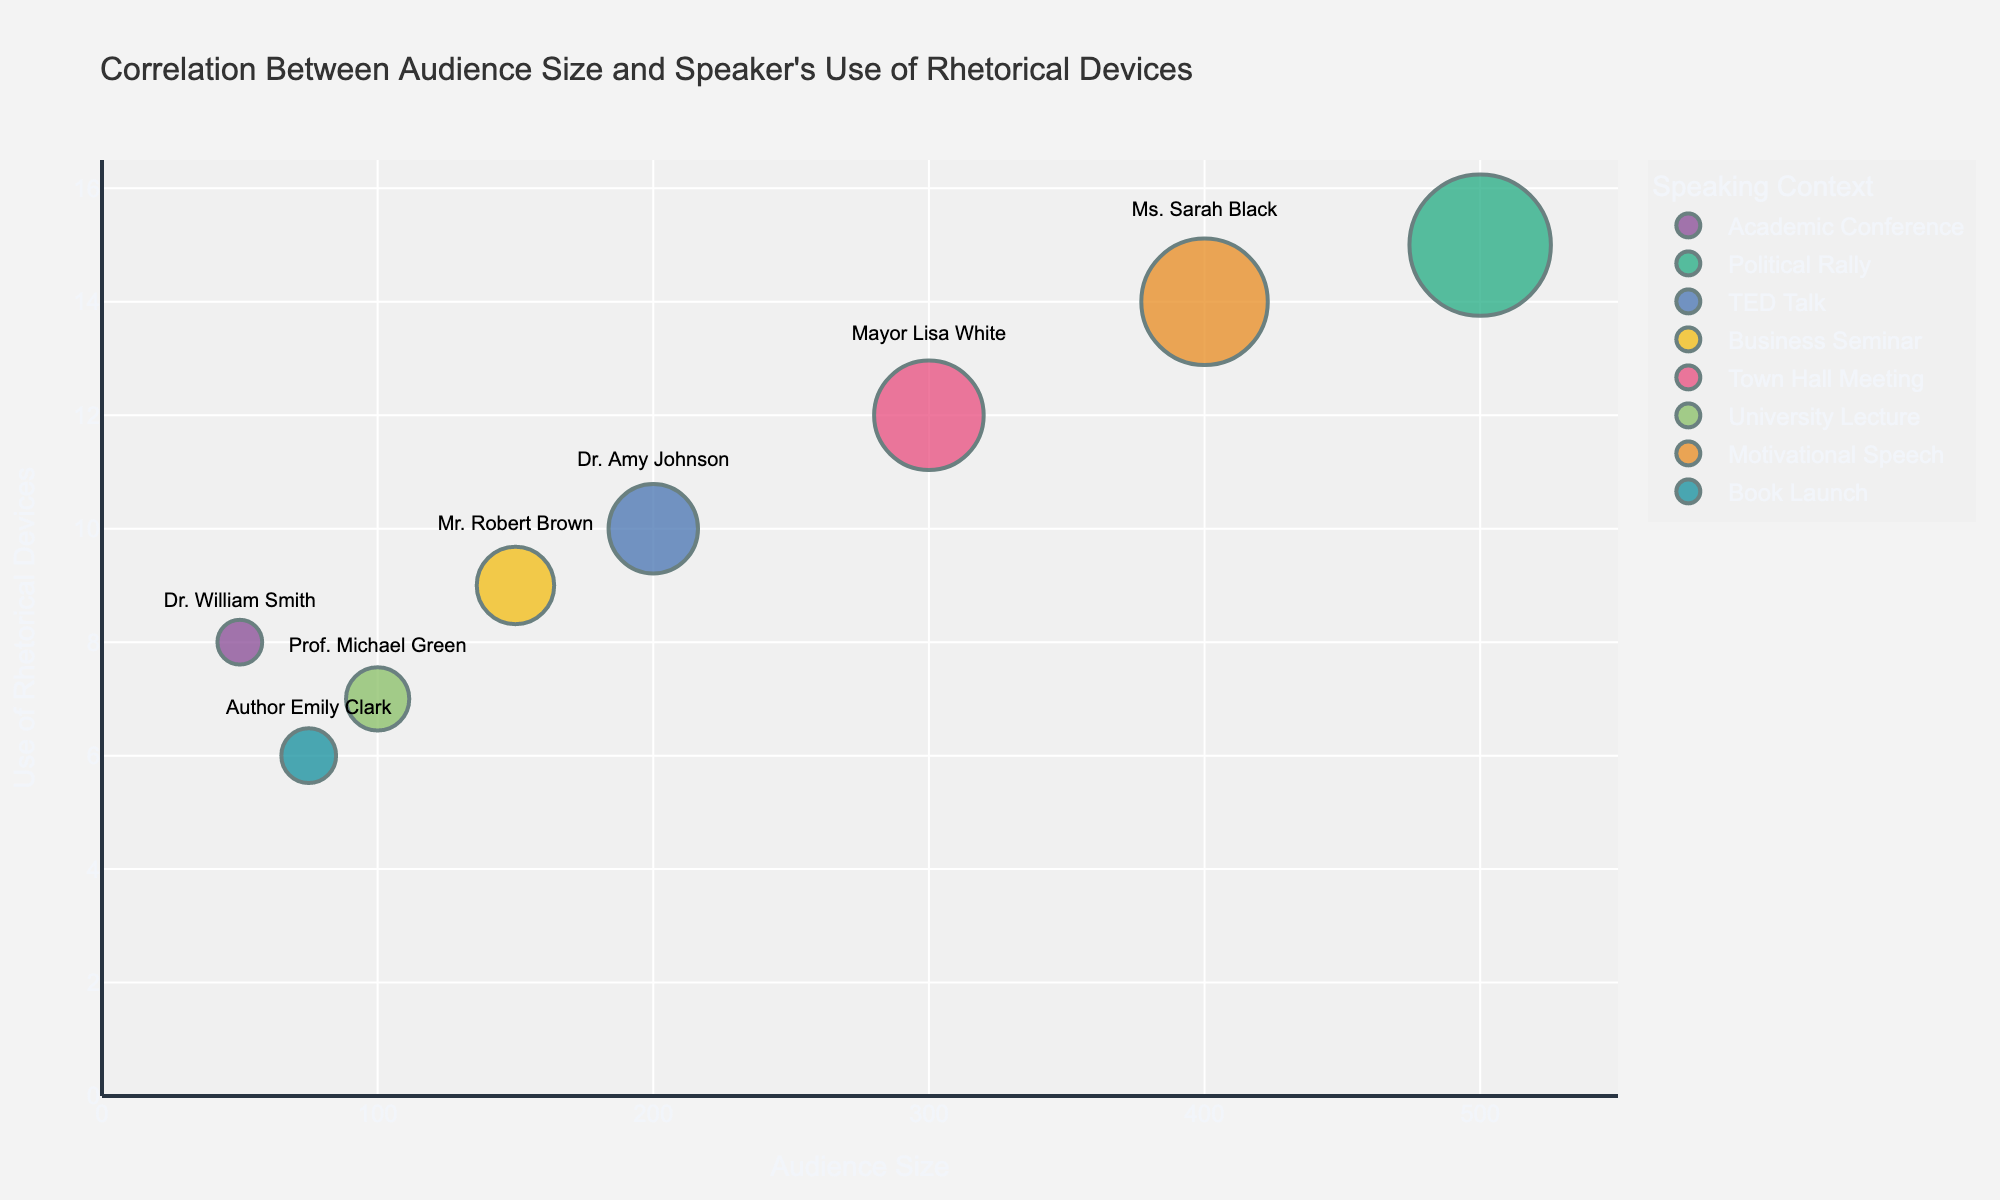What is the title of the chart? The title of the chart is typically found at the top and summarizes the main focus of the visualization. In this chart, the title reads "Correlation Between Audience Size and Speaker's Use of Rhetorical Devices".
Answer: Correlation Between Audience Size and Speaker's Use of Rhetorical Devices Which speaker had the largest audience size at the time of the presentation? The size of the bubbles indicates the audience size, and we can look at the corresponding labels to identify the speaker. The largest bubble represents Senator Jane Doe at the Political Rally with an audience size of 500.
Answer: Senator Jane Doe Who used the fewest rhetorical devices and in which context? The y-axis represents the use of rhetorical devices. The data point lowest on the y-axis marks the fewest rhetorical devices. That point corresponds to Author Emily Clark at the Book Launch, who used 6 rhetorical devices.
Answer: Author Emily Clark at Book Launch Compare the use of rhetorical devices between Dr. Amy Johnson in a TED Talk and Mayor Lisa White at a Town Hall Meeting. Who used more rhetorical devices? To compare, check the y-axis positions for both speakers. Dr. Amy Johnson used 10 rhetorical devices, while Mayor Lisa White used 12. Thus, Mayor Lisa White used more rhetorical devices.
Answer: Mayor Lisa White What's the average audience size for the contexts where the audience size is greater than 100? Identify the contexts with an audience size greater than 100 (Political Rally, TED Talk, Business Seminar, Town Hall Meeting, Motivational Speech). The audience sizes are 500, 200, 150, 300, and 400. Calculate the average as follows: (500 + 200 + 150 + 300 + 400) / 5 = 1550 / 5 = 310.
Answer: 310 Is there any context where the speaker used exactly 9 rhetorical devices? If so, which one? Locate the bubble corresponding to the y-axis value of 9. The bubble belongs to Mr. Robert Brown at a Business Seminar, indicating he used exactly 9 rhetorical devices.
Answer: Business Seminar (Mr. Robert Brown) What is the correlation trend between audience size and the use of rhetorical devices? Observe the general pattern of the bubbles. While there's no exact calculation provided, the chart suggests a trend where larger audiences correlate with a higher number of rhetorical devices.
Answer: Larger audiences -> More rhetorical devices How many contexts are represented in the chart, and what are they? Each bubble's color denotes a different speaking context. Counting the distinct colors and referencing the legend reveals there are 8 unique contexts: Academic Conference, Political Rally, TED Talk, Business Seminar, Town Hall Meeting, University Lecture, Motivational Speech, and Book Launch.
Answer: 8 contexts: Academic Conference, Political Rally, TED Talk, Business Seminar, Town Hall Meeting, University Lecture, Motivational Speech, Book Launch Which context had a speaker with an audience size less than 100? Find bubbles where the x-axis value (audience size) is less than 100. It corresponds to Dr. William Smith at an Academic Conference (50) and Author Emily Clark at a Book Launch (75).
Answer: Academic Conference and Book Launch If the average use of rhetorical devices across all contexts is calculated, what is it? Sum all the values of the rhetorical devices and divide by the number of data points (8). The values are 8, 15, 10, 9, 12, 7, 14, and 6, summing to 81. The average is thus 81 / 8 = 10.125, approximately 10.
Answer: Approximately 10 